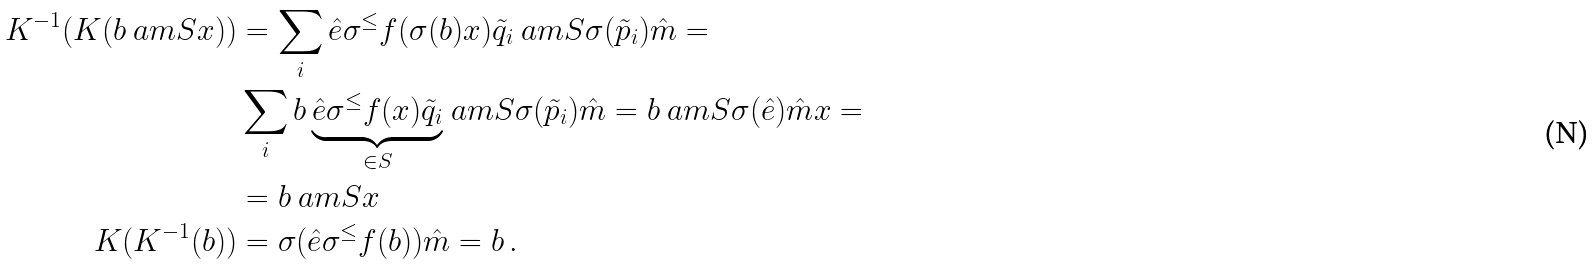Convert formula to latex. <formula><loc_0><loc_0><loc_500><loc_500>K ^ { - 1 } ( K ( b \ a m { S } x ) ) & = \sum _ { i } \hat { e } \sigma ^ { \leq } f ( \sigma ( b ) x ) \tilde { q } _ { i } \ a m { S } \sigma ( \tilde { p } _ { i } ) \hat { m } = \\ & \sum _ { i } b \, \underset { \in S } { \underbrace { \hat { e } \sigma ^ { \leq } f ( x ) \tilde { q } _ { i } } } \ a m { S } \sigma ( \tilde { p } _ { i } ) \hat { m } = b \ a m { S } \sigma ( \hat { e } ) \hat { m } x = \\ & = b \ a m { S } x \\ K ( K ^ { - 1 } ( b ) ) & = \sigma ( \hat { e } \sigma ^ { \leq } f ( b ) ) \hat { m } = b \, .</formula> 